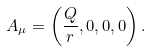<formula> <loc_0><loc_0><loc_500><loc_500>A _ { \mu } = \left ( \frac { Q } { r } , 0 , 0 , 0 \right ) .</formula> 